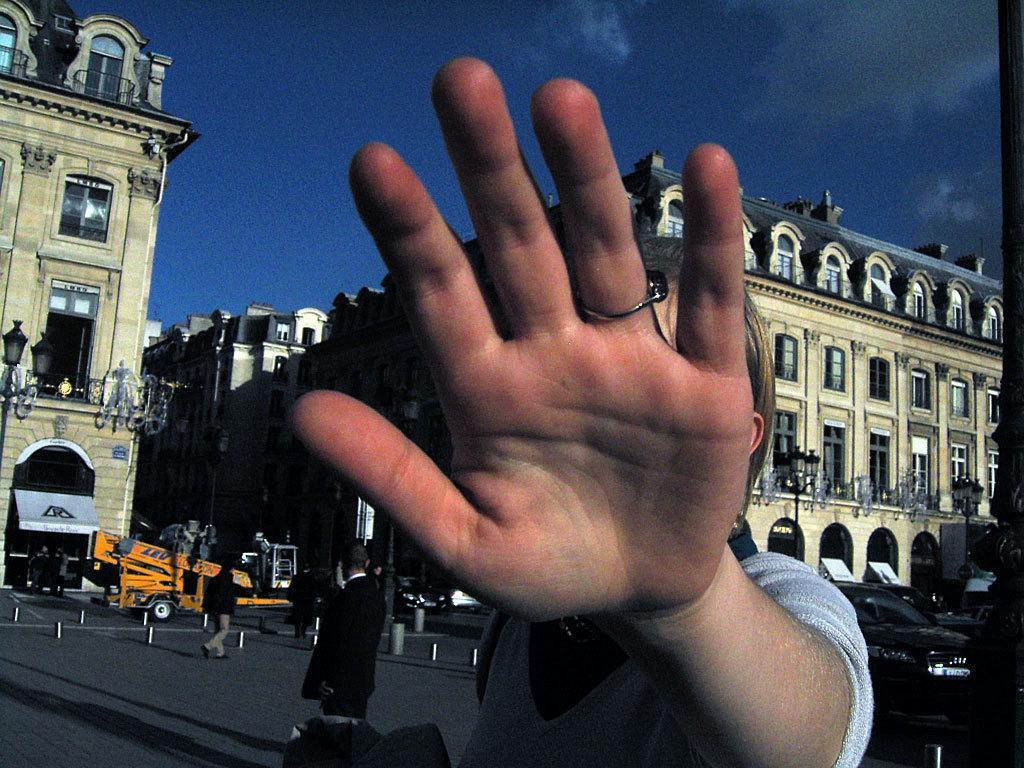How would you summarize this image in a sentence or two? In this image there are buildings. At the bottom we can see vehicles on the road and there are people. In the background there is sky. 